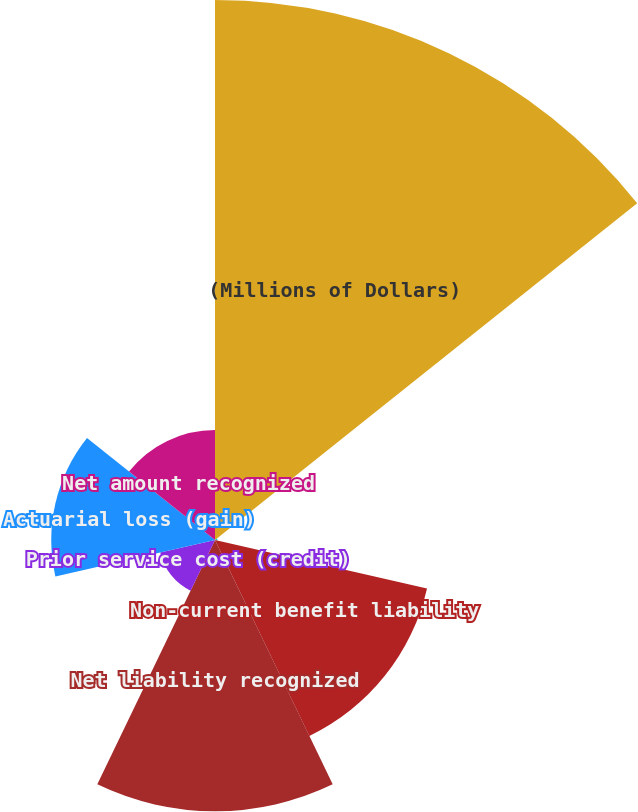<chart> <loc_0><loc_0><loc_500><loc_500><pie_chart><fcel>(Millions of Dollars)<fcel>Current benefit liability<fcel>Non-current benefit liability<fcel>Net liability recognized<fcel>Prior service cost (credit)<fcel>Actuarial loss (gain)<fcel>Net amount recognized<nl><fcel>39.68%<fcel>0.18%<fcel>15.98%<fcel>19.93%<fcel>4.13%<fcel>12.03%<fcel>8.08%<nl></chart> 